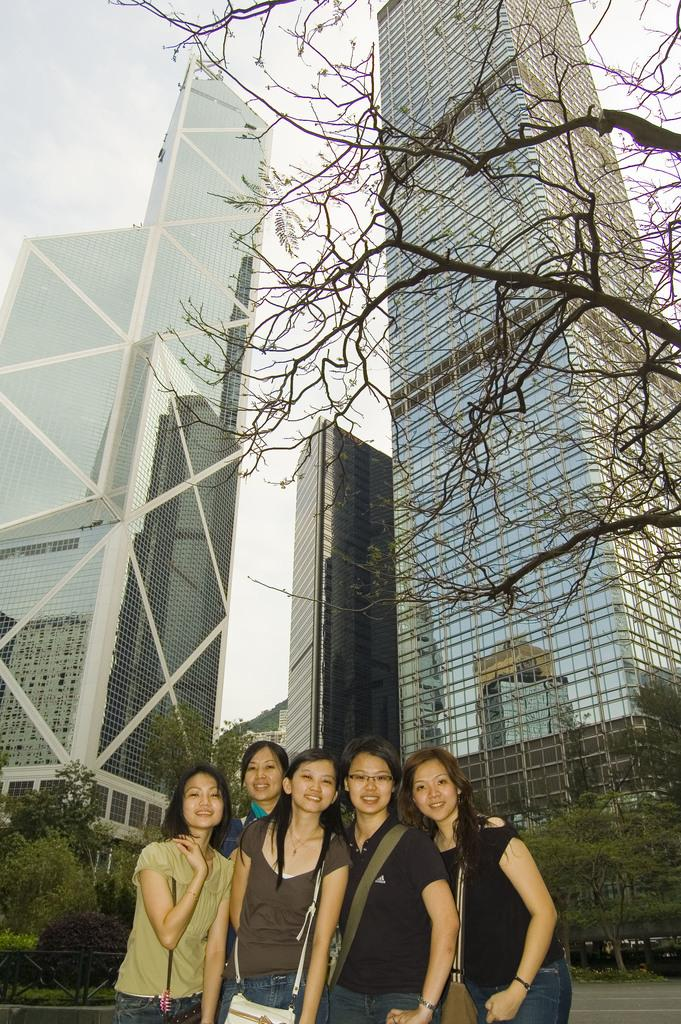What is the main subject in the foreground of the picture? There is a group of women in the foreground of the picture. What can be seen in the middle of the picture? There are trees and buildings in the middle of the picture. What is visible at the top of the picture? The sky is visible at the top of the picture. Can you tell me how many tigers are hiding in the trees in the picture? There are no tigers present in the picture; it only features a group of women, trees, buildings, and the sky. What type of vegetable can be seen growing in the picture? There is no specific vegetable mentioned or visible in the picture; it only features a group of women, trees, buildings, and the sky. 